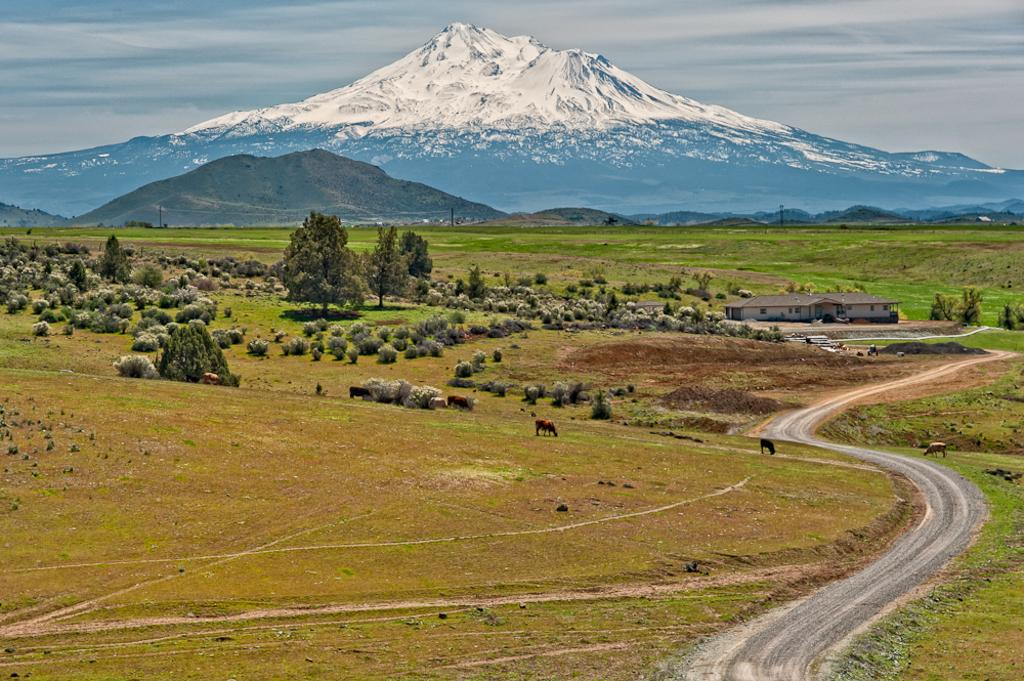What animals can be seen in the field in the image? There are cows grazing in the field in the image. What type of vegetation is present in the image? There are trees in the image. What is the color of the building in the image? The building in the image has a white color. What geographical features can be seen in the background of the image? There are hills in the background of the image. What is visible at the top of the image? The sky is visible at the top of the image. Can you tell me how many docks are visible in the image? There are no docks present in the image. What type of spring is used to hold the cows in the image? The cows are grazing freely in the field, and there are no springs or restraints visible in the image. 